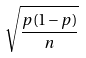<formula> <loc_0><loc_0><loc_500><loc_500>\sqrt { \frac { p ( 1 - p ) } { n } }</formula> 